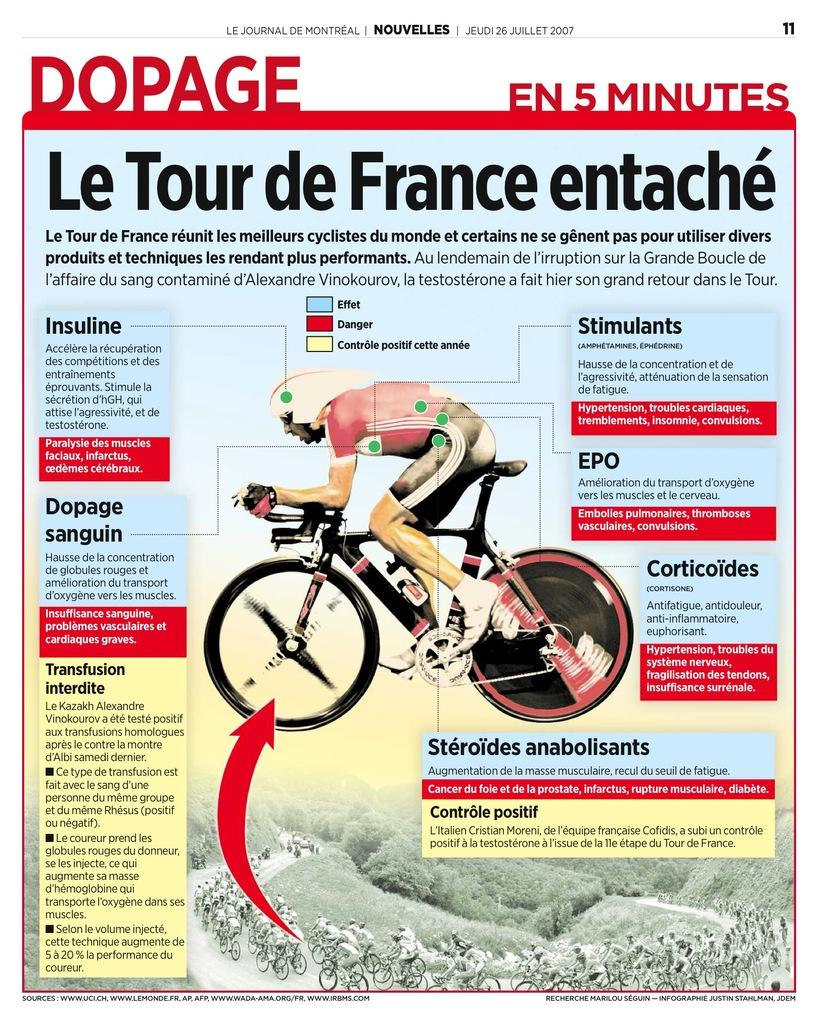What is the main subject in the image? There is a poster in the image. What else can be seen in the image besides the poster? There are people riding bicycles at the bottom of the image, and there is a bicycle and a person in the middle of the image. What is written on the poster? There is some text on the poster. Can you see a kitten playing with a knee in the image? No, there is no kitten or knee present in the image. What is the person in the middle of the image doing with the blow? There is no blow or any action involving a blow in the image; the person is simply riding a bicycle. 